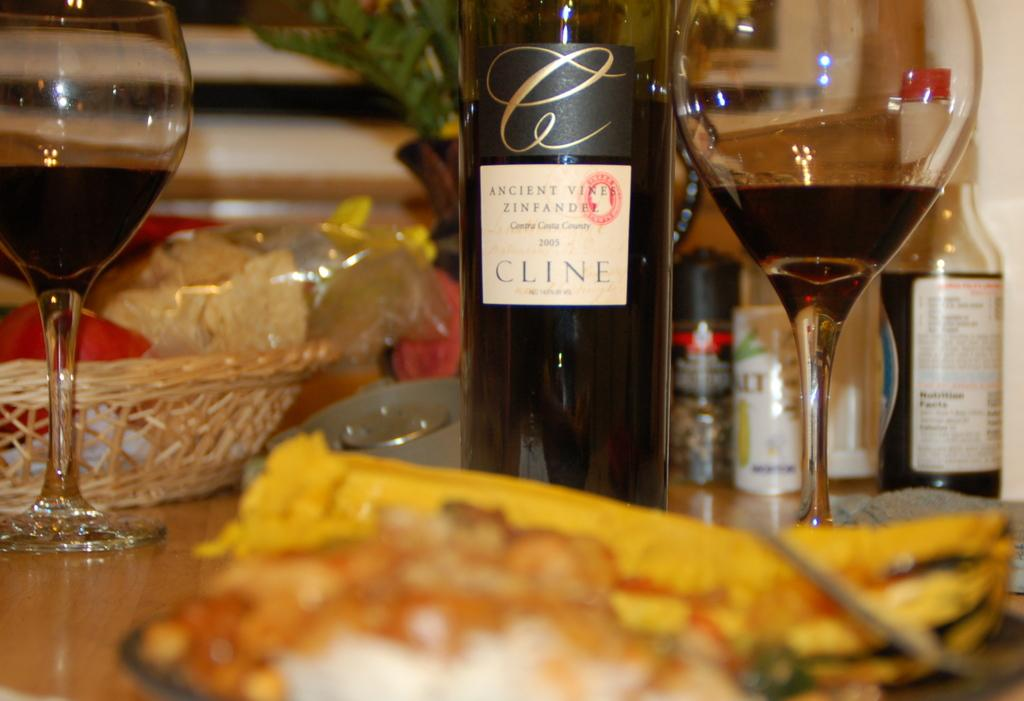How many glasses can be seen in the image? There are 2 glasses in the image. What else is present in the image besides the glasses? There are bottles and a basket in the image. What is the purpose of the basket in the image? The basket is used to hold items in the image. What adjustment needs to be made to the calendar in the image? There is no calendar present in the image, so no adjustment is needed. 